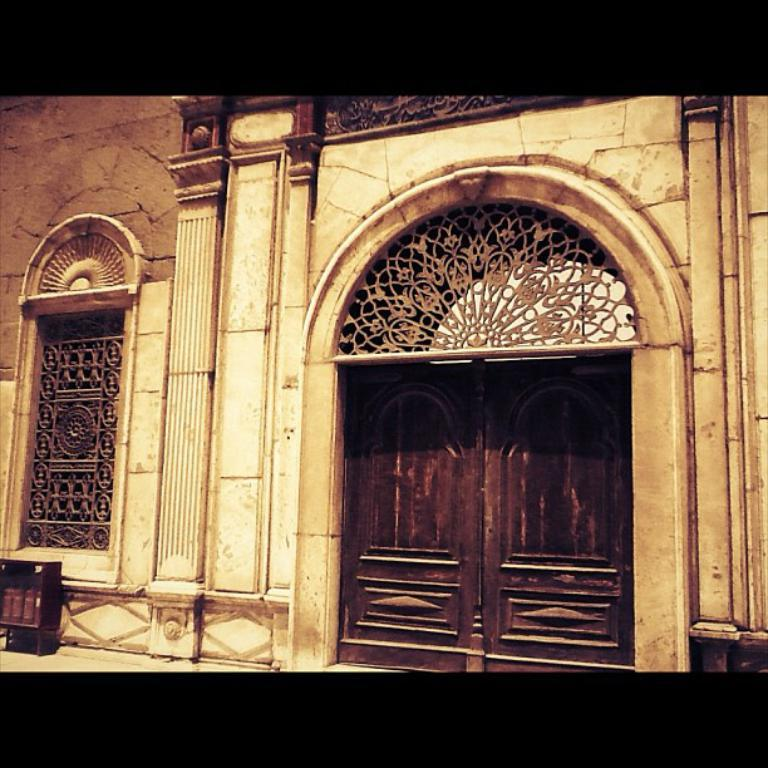What type of architectural feature can be seen in the image? There is a wall in the image. Are there any openings in the wall? Yes, there is a door and a window in the image. What is the design of the fence in the image? There is a fence design in the image. Can you describe the curtain hanging from the door in the image? There is no curtain hanging from the door in the image; it only shows a door, a wall, a window, and a fence design. 